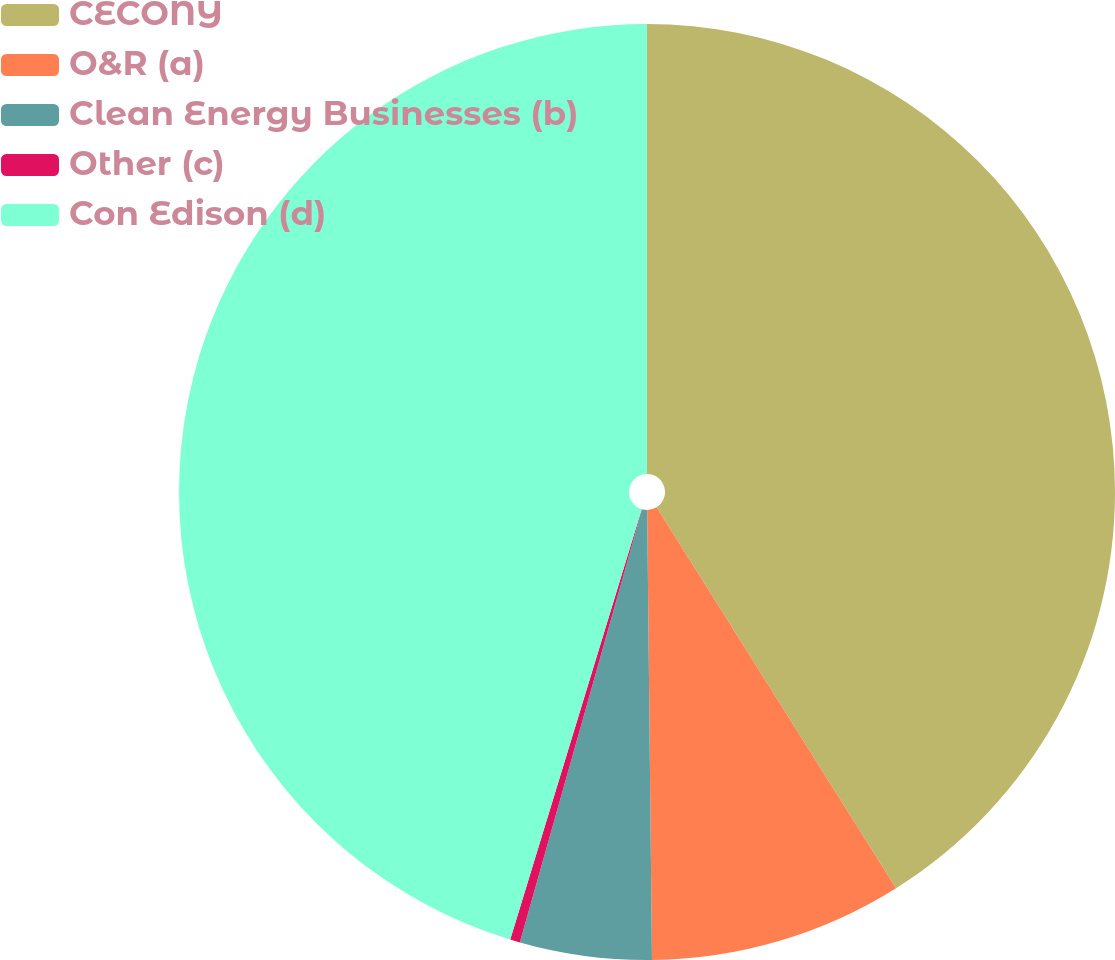<chart> <loc_0><loc_0><loc_500><loc_500><pie_chart><fcel>CECONY<fcel>O&R (a)<fcel>Clean Energy Businesses (b)<fcel>Other (c)<fcel>Con Edison (d)<nl><fcel>41.07%<fcel>8.76%<fcel>4.55%<fcel>0.34%<fcel>45.28%<nl></chart> 